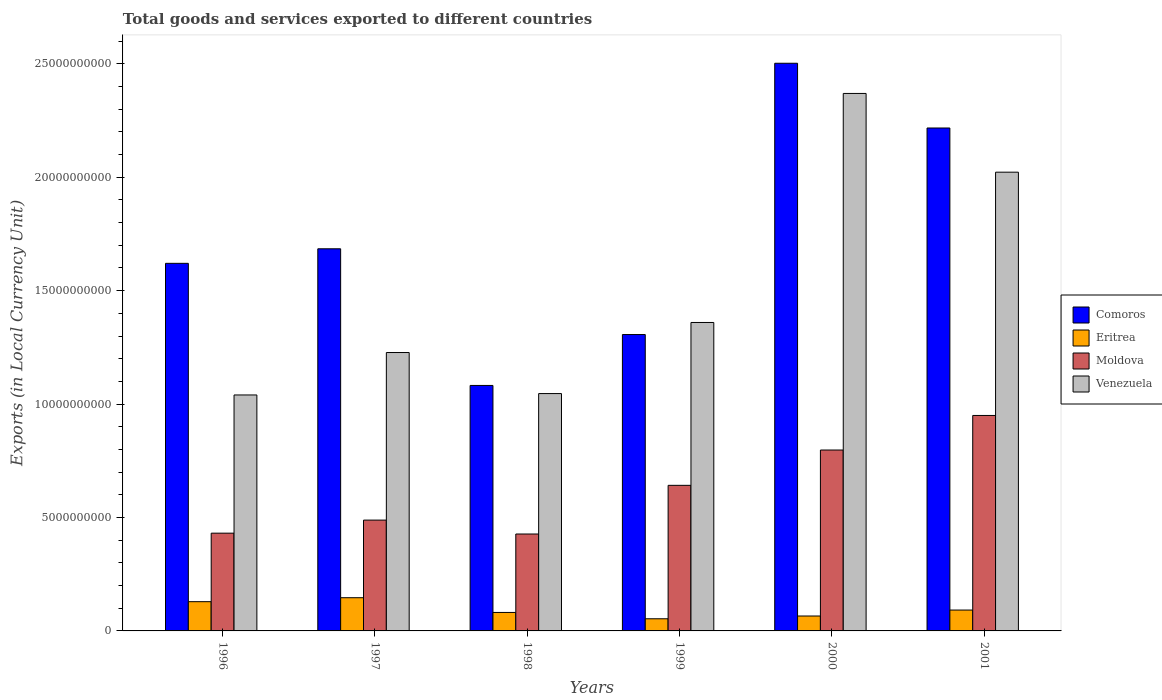How many groups of bars are there?
Provide a succinct answer. 6. Are the number of bars on each tick of the X-axis equal?
Offer a terse response. Yes. What is the Amount of goods and services exports in Venezuela in 2000?
Ensure brevity in your answer.  2.37e+1. Across all years, what is the maximum Amount of goods and services exports in Venezuela?
Make the answer very short. 2.37e+1. Across all years, what is the minimum Amount of goods and services exports in Eritrea?
Keep it short and to the point. 5.36e+08. In which year was the Amount of goods and services exports in Moldova maximum?
Give a very brief answer. 2001. What is the total Amount of goods and services exports in Venezuela in the graph?
Give a very brief answer. 9.06e+1. What is the difference between the Amount of goods and services exports in Moldova in 1998 and that in 1999?
Ensure brevity in your answer.  -2.15e+09. What is the difference between the Amount of goods and services exports in Venezuela in 1997 and the Amount of goods and services exports in Eritrea in 2001?
Your answer should be compact. 1.14e+1. What is the average Amount of goods and services exports in Venezuela per year?
Your answer should be compact. 1.51e+1. In the year 1998, what is the difference between the Amount of goods and services exports in Eritrea and Amount of goods and services exports in Comoros?
Offer a terse response. -1.00e+1. In how many years, is the Amount of goods and services exports in Comoros greater than 4000000000 LCU?
Provide a short and direct response. 6. What is the ratio of the Amount of goods and services exports in Venezuela in 1997 to that in 2000?
Your answer should be very brief. 0.52. Is the difference between the Amount of goods and services exports in Eritrea in 1999 and 2000 greater than the difference between the Amount of goods and services exports in Comoros in 1999 and 2000?
Your response must be concise. Yes. What is the difference between the highest and the second highest Amount of goods and services exports in Comoros?
Ensure brevity in your answer.  2.85e+09. What is the difference between the highest and the lowest Amount of goods and services exports in Venezuela?
Offer a terse response. 1.33e+1. In how many years, is the Amount of goods and services exports in Eritrea greater than the average Amount of goods and services exports in Eritrea taken over all years?
Your response must be concise. 2. Is it the case that in every year, the sum of the Amount of goods and services exports in Venezuela and Amount of goods and services exports in Comoros is greater than the sum of Amount of goods and services exports in Moldova and Amount of goods and services exports in Eritrea?
Keep it short and to the point. No. What does the 2nd bar from the left in 1997 represents?
Ensure brevity in your answer.  Eritrea. What does the 4th bar from the right in 2000 represents?
Your response must be concise. Comoros. Is it the case that in every year, the sum of the Amount of goods and services exports in Eritrea and Amount of goods and services exports in Comoros is greater than the Amount of goods and services exports in Venezuela?
Provide a succinct answer. Yes. How many years are there in the graph?
Offer a terse response. 6. What is the difference between two consecutive major ticks on the Y-axis?
Your answer should be compact. 5.00e+09. Are the values on the major ticks of Y-axis written in scientific E-notation?
Ensure brevity in your answer.  No. Where does the legend appear in the graph?
Your answer should be very brief. Center right. How many legend labels are there?
Your response must be concise. 4. How are the legend labels stacked?
Your answer should be compact. Vertical. What is the title of the graph?
Make the answer very short. Total goods and services exported to different countries. What is the label or title of the X-axis?
Keep it short and to the point. Years. What is the label or title of the Y-axis?
Provide a succinct answer. Exports (in Local Currency Unit). What is the Exports (in Local Currency Unit) of Comoros in 1996?
Your answer should be compact. 1.62e+1. What is the Exports (in Local Currency Unit) of Eritrea in 1996?
Give a very brief answer. 1.29e+09. What is the Exports (in Local Currency Unit) in Moldova in 1996?
Provide a short and direct response. 4.31e+09. What is the Exports (in Local Currency Unit) in Venezuela in 1996?
Offer a very short reply. 1.04e+1. What is the Exports (in Local Currency Unit) in Comoros in 1997?
Offer a very short reply. 1.68e+1. What is the Exports (in Local Currency Unit) of Eritrea in 1997?
Make the answer very short. 1.46e+09. What is the Exports (in Local Currency Unit) of Moldova in 1997?
Keep it short and to the point. 4.89e+09. What is the Exports (in Local Currency Unit) in Venezuela in 1997?
Provide a short and direct response. 1.23e+1. What is the Exports (in Local Currency Unit) in Comoros in 1998?
Keep it short and to the point. 1.08e+1. What is the Exports (in Local Currency Unit) in Eritrea in 1998?
Your answer should be compact. 8.14e+08. What is the Exports (in Local Currency Unit) in Moldova in 1998?
Ensure brevity in your answer.  4.27e+09. What is the Exports (in Local Currency Unit) in Venezuela in 1998?
Your answer should be very brief. 1.05e+1. What is the Exports (in Local Currency Unit) in Comoros in 1999?
Offer a terse response. 1.31e+1. What is the Exports (in Local Currency Unit) in Eritrea in 1999?
Your response must be concise. 5.36e+08. What is the Exports (in Local Currency Unit) of Moldova in 1999?
Give a very brief answer. 6.42e+09. What is the Exports (in Local Currency Unit) in Venezuela in 1999?
Ensure brevity in your answer.  1.36e+1. What is the Exports (in Local Currency Unit) in Comoros in 2000?
Provide a succinct answer. 2.50e+1. What is the Exports (in Local Currency Unit) of Eritrea in 2000?
Give a very brief answer. 6.57e+08. What is the Exports (in Local Currency Unit) of Moldova in 2000?
Offer a very short reply. 7.97e+09. What is the Exports (in Local Currency Unit) of Venezuela in 2000?
Give a very brief answer. 2.37e+1. What is the Exports (in Local Currency Unit) in Comoros in 2001?
Provide a short and direct response. 2.22e+1. What is the Exports (in Local Currency Unit) in Eritrea in 2001?
Ensure brevity in your answer.  9.20e+08. What is the Exports (in Local Currency Unit) in Moldova in 2001?
Your answer should be very brief. 9.50e+09. What is the Exports (in Local Currency Unit) in Venezuela in 2001?
Offer a terse response. 2.02e+1. Across all years, what is the maximum Exports (in Local Currency Unit) in Comoros?
Your answer should be very brief. 2.50e+1. Across all years, what is the maximum Exports (in Local Currency Unit) in Eritrea?
Offer a very short reply. 1.46e+09. Across all years, what is the maximum Exports (in Local Currency Unit) in Moldova?
Make the answer very short. 9.50e+09. Across all years, what is the maximum Exports (in Local Currency Unit) of Venezuela?
Provide a short and direct response. 2.37e+1. Across all years, what is the minimum Exports (in Local Currency Unit) of Comoros?
Your answer should be compact. 1.08e+1. Across all years, what is the minimum Exports (in Local Currency Unit) of Eritrea?
Provide a succinct answer. 5.36e+08. Across all years, what is the minimum Exports (in Local Currency Unit) in Moldova?
Provide a succinct answer. 4.27e+09. Across all years, what is the minimum Exports (in Local Currency Unit) in Venezuela?
Your answer should be compact. 1.04e+1. What is the total Exports (in Local Currency Unit) of Comoros in the graph?
Your answer should be compact. 1.04e+11. What is the total Exports (in Local Currency Unit) of Eritrea in the graph?
Provide a short and direct response. 5.68e+09. What is the total Exports (in Local Currency Unit) in Moldova in the graph?
Keep it short and to the point. 3.74e+1. What is the total Exports (in Local Currency Unit) of Venezuela in the graph?
Provide a short and direct response. 9.06e+1. What is the difference between the Exports (in Local Currency Unit) in Comoros in 1996 and that in 1997?
Give a very brief answer. -6.41e+08. What is the difference between the Exports (in Local Currency Unit) of Eritrea in 1996 and that in 1997?
Ensure brevity in your answer.  -1.75e+08. What is the difference between the Exports (in Local Currency Unit) of Moldova in 1996 and that in 1997?
Your response must be concise. -5.76e+08. What is the difference between the Exports (in Local Currency Unit) of Venezuela in 1996 and that in 1997?
Offer a terse response. -1.87e+09. What is the difference between the Exports (in Local Currency Unit) of Comoros in 1996 and that in 1998?
Offer a terse response. 5.38e+09. What is the difference between the Exports (in Local Currency Unit) in Eritrea in 1996 and that in 1998?
Offer a terse response. 4.75e+08. What is the difference between the Exports (in Local Currency Unit) of Moldova in 1996 and that in 1998?
Offer a terse response. 3.70e+07. What is the difference between the Exports (in Local Currency Unit) in Venezuela in 1996 and that in 1998?
Offer a very short reply. -6.14e+07. What is the difference between the Exports (in Local Currency Unit) of Comoros in 1996 and that in 1999?
Make the answer very short. 3.14e+09. What is the difference between the Exports (in Local Currency Unit) of Eritrea in 1996 and that in 1999?
Provide a short and direct response. 7.53e+08. What is the difference between the Exports (in Local Currency Unit) in Moldova in 1996 and that in 1999?
Ensure brevity in your answer.  -2.11e+09. What is the difference between the Exports (in Local Currency Unit) of Venezuela in 1996 and that in 1999?
Ensure brevity in your answer.  -3.20e+09. What is the difference between the Exports (in Local Currency Unit) in Comoros in 1996 and that in 2000?
Offer a very short reply. -8.82e+09. What is the difference between the Exports (in Local Currency Unit) of Eritrea in 1996 and that in 2000?
Make the answer very short. 6.31e+08. What is the difference between the Exports (in Local Currency Unit) of Moldova in 1996 and that in 2000?
Keep it short and to the point. -3.66e+09. What is the difference between the Exports (in Local Currency Unit) in Venezuela in 1996 and that in 2000?
Your answer should be very brief. -1.33e+1. What is the difference between the Exports (in Local Currency Unit) in Comoros in 1996 and that in 2001?
Offer a very short reply. -5.97e+09. What is the difference between the Exports (in Local Currency Unit) in Eritrea in 1996 and that in 2001?
Offer a very short reply. 3.69e+08. What is the difference between the Exports (in Local Currency Unit) in Moldova in 1996 and that in 2001?
Your answer should be very brief. -5.19e+09. What is the difference between the Exports (in Local Currency Unit) in Venezuela in 1996 and that in 2001?
Give a very brief answer. -9.82e+09. What is the difference between the Exports (in Local Currency Unit) in Comoros in 1997 and that in 1998?
Provide a short and direct response. 6.02e+09. What is the difference between the Exports (in Local Currency Unit) of Eritrea in 1997 and that in 1998?
Keep it short and to the point. 6.50e+08. What is the difference between the Exports (in Local Currency Unit) of Moldova in 1997 and that in 1998?
Offer a very short reply. 6.13e+08. What is the difference between the Exports (in Local Currency Unit) of Venezuela in 1997 and that in 1998?
Make the answer very short. 1.81e+09. What is the difference between the Exports (in Local Currency Unit) of Comoros in 1997 and that in 1999?
Keep it short and to the point. 3.78e+09. What is the difference between the Exports (in Local Currency Unit) of Eritrea in 1997 and that in 1999?
Offer a very short reply. 9.28e+08. What is the difference between the Exports (in Local Currency Unit) in Moldova in 1997 and that in 1999?
Make the answer very short. -1.53e+09. What is the difference between the Exports (in Local Currency Unit) of Venezuela in 1997 and that in 1999?
Keep it short and to the point. -1.32e+09. What is the difference between the Exports (in Local Currency Unit) in Comoros in 1997 and that in 2000?
Make the answer very short. -8.18e+09. What is the difference between the Exports (in Local Currency Unit) in Eritrea in 1997 and that in 2000?
Offer a very short reply. 8.06e+08. What is the difference between the Exports (in Local Currency Unit) of Moldova in 1997 and that in 2000?
Make the answer very short. -3.09e+09. What is the difference between the Exports (in Local Currency Unit) of Venezuela in 1997 and that in 2000?
Offer a very short reply. -1.14e+1. What is the difference between the Exports (in Local Currency Unit) in Comoros in 1997 and that in 2001?
Keep it short and to the point. -5.32e+09. What is the difference between the Exports (in Local Currency Unit) in Eritrea in 1997 and that in 2001?
Provide a short and direct response. 5.44e+08. What is the difference between the Exports (in Local Currency Unit) in Moldova in 1997 and that in 2001?
Ensure brevity in your answer.  -4.61e+09. What is the difference between the Exports (in Local Currency Unit) in Venezuela in 1997 and that in 2001?
Give a very brief answer. -7.95e+09. What is the difference between the Exports (in Local Currency Unit) in Comoros in 1998 and that in 1999?
Provide a short and direct response. -2.24e+09. What is the difference between the Exports (in Local Currency Unit) in Eritrea in 1998 and that in 1999?
Your answer should be very brief. 2.79e+08. What is the difference between the Exports (in Local Currency Unit) of Moldova in 1998 and that in 1999?
Ensure brevity in your answer.  -2.15e+09. What is the difference between the Exports (in Local Currency Unit) of Venezuela in 1998 and that in 1999?
Offer a terse response. -3.13e+09. What is the difference between the Exports (in Local Currency Unit) in Comoros in 1998 and that in 2000?
Make the answer very short. -1.42e+1. What is the difference between the Exports (in Local Currency Unit) in Eritrea in 1998 and that in 2000?
Your answer should be very brief. 1.57e+08. What is the difference between the Exports (in Local Currency Unit) in Moldova in 1998 and that in 2000?
Keep it short and to the point. -3.70e+09. What is the difference between the Exports (in Local Currency Unit) in Venezuela in 1998 and that in 2000?
Your answer should be very brief. -1.32e+1. What is the difference between the Exports (in Local Currency Unit) in Comoros in 1998 and that in 2001?
Provide a succinct answer. -1.13e+1. What is the difference between the Exports (in Local Currency Unit) of Eritrea in 1998 and that in 2001?
Provide a succinct answer. -1.05e+08. What is the difference between the Exports (in Local Currency Unit) in Moldova in 1998 and that in 2001?
Give a very brief answer. -5.23e+09. What is the difference between the Exports (in Local Currency Unit) of Venezuela in 1998 and that in 2001?
Your response must be concise. -9.76e+09. What is the difference between the Exports (in Local Currency Unit) in Comoros in 1999 and that in 2000?
Keep it short and to the point. -1.20e+1. What is the difference between the Exports (in Local Currency Unit) in Eritrea in 1999 and that in 2000?
Your answer should be very brief. -1.22e+08. What is the difference between the Exports (in Local Currency Unit) in Moldova in 1999 and that in 2000?
Offer a very short reply. -1.56e+09. What is the difference between the Exports (in Local Currency Unit) of Venezuela in 1999 and that in 2000?
Offer a very short reply. -1.01e+1. What is the difference between the Exports (in Local Currency Unit) of Comoros in 1999 and that in 2001?
Offer a terse response. -9.10e+09. What is the difference between the Exports (in Local Currency Unit) in Eritrea in 1999 and that in 2001?
Your answer should be compact. -3.84e+08. What is the difference between the Exports (in Local Currency Unit) of Moldova in 1999 and that in 2001?
Provide a short and direct response. -3.08e+09. What is the difference between the Exports (in Local Currency Unit) of Venezuela in 1999 and that in 2001?
Keep it short and to the point. -6.63e+09. What is the difference between the Exports (in Local Currency Unit) in Comoros in 2000 and that in 2001?
Ensure brevity in your answer.  2.85e+09. What is the difference between the Exports (in Local Currency Unit) in Eritrea in 2000 and that in 2001?
Offer a very short reply. -2.62e+08. What is the difference between the Exports (in Local Currency Unit) in Moldova in 2000 and that in 2001?
Make the answer very short. -1.52e+09. What is the difference between the Exports (in Local Currency Unit) in Venezuela in 2000 and that in 2001?
Provide a succinct answer. 3.47e+09. What is the difference between the Exports (in Local Currency Unit) of Comoros in 1996 and the Exports (in Local Currency Unit) of Eritrea in 1997?
Your response must be concise. 1.47e+1. What is the difference between the Exports (in Local Currency Unit) in Comoros in 1996 and the Exports (in Local Currency Unit) in Moldova in 1997?
Your answer should be very brief. 1.13e+1. What is the difference between the Exports (in Local Currency Unit) in Comoros in 1996 and the Exports (in Local Currency Unit) in Venezuela in 1997?
Ensure brevity in your answer.  3.93e+09. What is the difference between the Exports (in Local Currency Unit) of Eritrea in 1996 and the Exports (in Local Currency Unit) of Moldova in 1997?
Ensure brevity in your answer.  -3.60e+09. What is the difference between the Exports (in Local Currency Unit) of Eritrea in 1996 and the Exports (in Local Currency Unit) of Venezuela in 1997?
Offer a very short reply. -1.10e+1. What is the difference between the Exports (in Local Currency Unit) of Moldova in 1996 and the Exports (in Local Currency Unit) of Venezuela in 1997?
Your answer should be compact. -7.96e+09. What is the difference between the Exports (in Local Currency Unit) of Comoros in 1996 and the Exports (in Local Currency Unit) of Eritrea in 1998?
Your answer should be very brief. 1.54e+1. What is the difference between the Exports (in Local Currency Unit) of Comoros in 1996 and the Exports (in Local Currency Unit) of Moldova in 1998?
Your response must be concise. 1.19e+1. What is the difference between the Exports (in Local Currency Unit) of Comoros in 1996 and the Exports (in Local Currency Unit) of Venezuela in 1998?
Give a very brief answer. 5.74e+09. What is the difference between the Exports (in Local Currency Unit) of Eritrea in 1996 and the Exports (in Local Currency Unit) of Moldova in 1998?
Your response must be concise. -2.98e+09. What is the difference between the Exports (in Local Currency Unit) in Eritrea in 1996 and the Exports (in Local Currency Unit) in Venezuela in 1998?
Provide a succinct answer. -9.17e+09. What is the difference between the Exports (in Local Currency Unit) of Moldova in 1996 and the Exports (in Local Currency Unit) of Venezuela in 1998?
Offer a very short reply. -6.15e+09. What is the difference between the Exports (in Local Currency Unit) of Comoros in 1996 and the Exports (in Local Currency Unit) of Eritrea in 1999?
Provide a short and direct response. 1.57e+1. What is the difference between the Exports (in Local Currency Unit) of Comoros in 1996 and the Exports (in Local Currency Unit) of Moldova in 1999?
Make the answer very short. 9.79e+09. What is the difference between the Exports (in Local Currency Unit) of Comoros in 1996 and the Exports (in Local Currency Unit) of Venezuela in 1999?
Your response must be concise. 2.61e+09. What is the difference between the Exports (in Local Currency Unit) of Eritrea in 1996 and the Exports (in Local Currency Unit) of Moldova in 1999?
Your answer should be very brief. -5.13e+09. What is the difference between the Exports (in Local Currency Unit) in Eritrea in 1996 and the Exports (in Local Currency Unit) in Venezuela in 1999?
Offer a very short reply. -1.23e+1. What is the difference between the Exports (in Local Currency Unit) of Moldova in 1996 and the Exports (in Local Currency Unit) of Venezuela in 1999?
Provide a short and direct response. -9.29e+09. What is the difference between the Exports (in Local Currency Unit) of Comoros in 1996 and the Exports (in Local Currency Unit) of Eritrea in 2000?
Provide a short and direct response. 1.55e+1. What is the difference between the Exports (in Local Currency Unit) of Comoros in 1996 and the Exports (in Local Currency Unit) of Moldova in 2000?
Keep it short and to the point. 8.23e+09. What is the difference between the Exports (in Local Currency Unit) of Comoros in 1996 and the Exports (in Local Currency Unit) of Venezuela in 2000?
Your answer should be compact. -7.49e+09. What is the difference between the Exports (in Local Currency Unit) of Eritrea in 1996 and the Exports (in Local Currency Unit) of Moldova in 2000?
Your answer should be compact. -6.69e+09. What is the difference between the Exports (in Local Currency Unit) in Eritrea in 1996 and the Exports (in Local Currency Unit) in Venezuela in 2000?
Your answer should be very brief. -2.24e+1. What is the difference between the Exports (in Local Currency Unit) in Moldova in 1996 and the Exports (in Local Currency Unit) in Venezuela in 2000?
Give a very brief answer. -1.94e+1. What is the difference between the Exports (in Local Currency Unit) in Comoros in 1996 and the Exports (in Local Currency Unit) in Eritrea in 2001?
Your response must be concise. 1.53e+1. What is the difference between the Exports (in Local Currency Unit) in Comoros in 1996 and the Exports (in Local Currency Unit) in Moldova in 2001?
Give a very brief answer. 6.71e+09. What is the difference between the Exports (in Local Currency Unit) in Comoros in 1996 and the Exports (in Local Currency Unit) in Venezuela in 2001?
Provide a short and direct response. -4.02e+09. What is the difference between the Exports (in Local Currency Unit) in Eritrea in 1996 and the Exports (in Local Currency Unit) in Moldova in 2001?
Offer a very short reply. -8.21e+09. What is the difference between the Exports (in Local Currency Unit) of Eritrea in 1996 and the Exports (in Local Currency Unit) of Venezuela in 2001?
Your answer should be very brief. -1.89e+1. What is the difference between the Exports (in Local Currency Unit) in Moldova in 1996 and the Exports (in Local Currency Unit) in Venezuela in 2001?
Make the answer very short. -1.59e+1. What is the difference between the Exports (in Local Currency Unit) of Comoros in 1997 and the Exports (in Local Currency Unit) of Eritrea in 1998?
Your answer should be compact. 1.60e+1. What is the difference between the Exports (in Local Currency Unit) of Comoros in 1997 and the Exports (in Local Currency Unit) of Moldova in 1998?
Your response must be concise. 1.26e+1. What is the difference between the Exports (in Local Currency Unit) in Comoros in 1997 and the Exports (in Local Currency Unit) in Venezuela in 1998?
Offer a very short reply. 6.38e+09. What is the difference between the Exports (in Local Currency Unit) of Eritrea in 1997 and the Exports (in Local Currency Unit) of Moldova in 1998?
Your answer should be very brief. -2.81e+09. What is the difference between the Exports (in Local Currency Unit) in Eritrea in 1997 and the Exports (in Local Currency Unit) in Venezuela in 1998?
Give a very brief answer. -9.00e+09. What is the difference between the Exports (in Local Currency Unit) in Moldova in 1997 and the Exports (in Local Currency Unit) in Venezuela in 1998?
Your answer should be very brief. -5.58e+09. What is the difference between the Exports (in Local Currency Unit) in Comoros in 1997 and the Exports (in Local Currency Unit) in Eritrea in 1999?
Offer a very short reply. 1.63e+1. What is the difference between the Exports (in Local Currency Unit) in Comoros in 1997 and the Exports (in Local Currency Unit) in Moldova in 1999?
Your answer should be very brief. 1.04e+1. What is the difference between the Exports (in Local Currency Unit) of Comoros in 1997 and the Exports (in Local Currency Unit) of Venezuela in 1999?
Provide a short and direct response. 3.25e+09. What is the difference between the Exports (in Local Currency Unit) in Eritrea in 1997 and the Exports (in Local Currency Unit) in Moldova in 1999?
Your answer should be very brief. -4.95e+09. What is the difference between the Exports (in Local Currency Unit) of Eritrea in 1997 and the Exports (in Local Currency Unit) of Venezuela in 1999?
Your answer should be very brief. -1.21e+1. What is the difference between the Exports (in Local Currency Unit) in Moldova in 1997 and the Exports (in Local Currency Unit) in Venezuela in 1999?
Make the answer very short. -8.71e+09. What is the difference between the Exports (in Local Currency Unit) in Comoros in 1997 and the Exports (in Local Currency Unit) in Eritrea in 2000?
Provide a succinct answer. 1.62e+1. What is the difference between the Exports (in Local Currency Unit) in Comoros in 1997 and the Exports (in Local Currency Unit) in Moldova in 2000?
Offer a terse response. 8.87e+09. What is the difference between the Exports (in Local Currency Unit) of Comoros in 1997 and the Exports (in Local Currency Unit) of Venezuela in 2000?
Your answer should be compact. -6.85e+09. What is the difference between the Exports (in Local Currency Unit) in Eritrea in 1997 and the Exports (in Local Currency Unit) in Moldova in 2000?
Offer a very short reply. -6.51e+09. What is the difference between the Exports (in Local Currency Unit) of Eritrea in 1997 and the Exports (in Local Currency Unit) of Venezuela in 2000?
Provide a short and direct response. -2.22e+1. What is the difference between the Exports (in Local Currency Unit) of Moldova in 1997 and the Exports (in Local Currency Unit) of Venezuela in 2000?
Provide a succinct answer. -1.88e+1. What is the difference between the Exports (in Local Currency Unit) of Comoros in 1997 and the Exports (in Local Currency Unit) of Eritrea in 2001?
Provide a succinct answer. 1.59e+1. What is the difference between the Exports (in Local Currency Unit) of Comoros in 1997 and the Exports (in Local Currency Unit) of Moldova in 2001?
Offer a very short reply. 7.35e+09. What is the difference between the Exports (in Local Currency Unit) in Comoros in 1997 and the Exports (in Local Currency Unit) in Venezuela in 2001?
Ensure brevity in your answer.  -3.38e+09. What is the difference between the Exports (in Local Currency Unit) of Eritrea in 1997 and the Exports (in Local Currency Unit) of Moldova in 2001?
Your response must be concise. -8.03e+09. What is the difference between the Exports (in Local Currency Unit) of Eritrea in 1997 and the Exports (in Local Currency Unit) of Venezuela in 2001?
Provide a short and direct response. -1.88e+1. What is the difference between the Exports (in Local Currency Unit) of Moldova in 1997 and the Exports (in Local Currency Unit) of Venezuela in 2001?
Make the answer very short. -1.53e+1. What is the difference between the Exports (in Local Currency Unit) of Comoros in 1998 and the Exports (in Local Currency Unit) of Eritrea in 1999?
Keep it short and to the point. 1.03e+1. What is the difference between the Exports (in Local Currency Unit) of Comoros in 1998 and the Exports (in Local Currency Unit) of Moldova in 1999?
Make the answer very short. 4.40e+09. What is the difference between the Exports (in Local Currency Unit) of Comoros in 1998 and the Exports (in Local Currency Unit) of Venezuela in 1999?
Make the answer very short. -2.78e+09. What is the difference between the Exports (in Local Currency Unit) in Eritrea in 1998 and the Exports (in Local Currency Unit) in Moldova in 1999?
Keep it short and to the point. -5.60e+09. What is the difference between the Exports (in Local Currency Unit) of Eritrea in 1998 and the Exports (in Local Currency Unit) of Venezuela in 1999?
Offer a very short reply. -1.28e+1. What is the difference between the Exports (in Local Currency Unit) in Moldova in 1998 and the Exports (in Local Currency Unit) in Venezuela in 1999?
Make the answer very short. -9.32e+09. What is the difference between the Exports (in Local Currency Unit) in Comoros in 1998 and the Exports (in Local Currency Unit) in Eritrea in 2000?
Your response must be concise. 1.02e+1. What is the difference between the Exports (in Local Currency Unit) in Comoros in 1998 and the Exports (in Local Currency Unit) in Moldova in 2000?
Provide a succinct answer. 2.85e+09. What is the difference between the Exports (in Local Currency Unit) of Comoros in 1998 and the Exports (in Local Currency Unit) of Venezuela in 2000?
Offer a very short reply. -1.29e+1. What is the difference between the Exports (in Local Currency Unit) in Eritrea in 1998 and the Exports (in Local Currency Unit) in Moldova in 2000?
Your answer should be compact. -7.16e+09. What is the difference between the Exports (in Local Currency Unit) of Eritrea in 1998 and the Exports (in Local Currency Unit) of Venezuela in 2000?
Provide a succinct answer. -2.29e+1. What is the difference between the Exports (in Local Currency Unit) in Moldova in 1998 and the Exports (in Local Currency Unit) in Venezuela in 2000?
Your answer should be very brief. -1.94e+1. What is the difference between the Exports (in Local Currency Unit) of Comoros in 1998 and the Exports (in Local Currency Unit) of Eritrea in 2001?
Provide a short and direct response. 9.90e+09. What is the difference between the Exports (in Local Currency Unit) in Comoros in 1998 and the Exports (in Local Currency Unit) in Moldova in 2001?
Give a very brief answer. 1.32e+09. What is the difference between the Exports (in Local Currency Unit) in Comoros in 1998 and the Exports (in Local Currency Unit) in Venezuela in 2001?
Offer a very short reply. -9.40e+09. What is the difference between the Exports (in Local Currency Unit) in Eritrea in 1998 and the Exports (in Local Currency Unit) in Moldova in 2001?
Your answer should be very brief. -8.68e+09. What is the difference between the Exports (in Local Currency Unit) of Eritrea in 1998 and the Exports (in Local Currency Unit) of Venezuela in 2001?
Your answer should be compact. -1.94e+1. What is the difference between the Exports (in Local Currency Unit) of Moldova in 1998 and the Exports (in Local Currency Unit) of Venezuela in 2001?
Offer a very short reply. -1.59e+1. What is the difference between the Exports (in Local Currency Unit) of Comoros in 1999 and the Exports (in Local Currency Unit) of Eritrea in 2000?
Your response must be concise. 1.24e+1. What is the difference between the Exports (in Local Currency Unit) in Comoros in 1999 and the Exports (in Local Currency Unit) in Moldova in 2000?
Offer a terse response. 5.09e+09. What is the difference between the Exports (in Local Currency Unit) of Comoros in 1999 and the Exports (in Local Currency Unit) of Venezuela in 2000?
Offer a terse response. -1.06e+1. What is the difference between the Exports (in Local Currency Unit) in Eritrea in 1999 and the Exports (in Local Currency Unit) in Moldova in 2000?
Offer a very short reply. -7.44e+09. What is the difference between the Exports (in Local Currency Unit) in Eritrea in 1999 and the Exports (in Local Currency Unit) in Venezuela in 2000?
Ensure brevity in your answer.  -2.32e+1. What is the difference between the Exports (in Local Currency Unit) of Moldova in 1999 and the Exports (in Local Currency Unit) of Venezuela in 2000?
Keep it short and to the point. -1.73e+1. What is the difference between the Exports (in Local Currency Unit) in Comoros in 1999 and the Exports (in Local Currency Unit) in Eritrea in 2001?
Keep it short and to the point. 1.21e+1. What is the difference between the Exports (in Local Currency Unit) in Comoros in 1999 and the Exports (in Local Currency Unit) in Moldova in 2001?
Ensure brevity in your answer.  3.57e+09. What is the difference between the Exports (in Local Currency Unit) of Comoros in 1999 and the Exports (in Local Currency Unit) of Venezuela in 2001?
Your answer should be compact. -7.16e+09. What is the difference between the Exports (in Local Currency Unit) in Eritrea in 1999 and the Exports (in Local Currency Unit) in Moldova in 2001?
Give a very brief answer. -8.96e+09. What is the difference between the Exports (in Local Currency Unit) of Eritrea in 1999 and the Exports (in Local Currency Unit) of Venezuela in 2001?
Provide a succinct answer. -1.97e+1. What is the difference between the Exports (in Local Currency Unit) in Moldova in 1999 and the Exports (in Local Currency Unit) in Venezuela in 2001?
Give a very brief answer. -1.38e+1. What is the difference between the Exports (in Local Currency Unit) of Comoros in 2000 and the Exports (in Local Currency Unit) of Eritrea in 2001?
Offer a terse response. 2.41e+1. What is the difference between the Exports (in Local Currency Unit) in Comoros in 2000 and the Exports (in Local Currency Unit) in Moldova in 2001?
Give a very brief answer. 1.55e+1. What is the difference between the Exports (in Local Currency Unit) of Comoros in 2000 and the Exports (in Local Currency Unit) of Venezuela in 2001?
Give a very brief answer. 4.80e+09. What is the difference between the Exports (in Local Currency Unit) of Eritrea in 2000 and the Exports (in Local Currency Unit) of Moldova in 2001?
Your answer should be very brief. -8.84e+09. What is the difference between the Exports (in Local Currency Unit) in Eritrea in 2000 and the Exports (in Local Currency Unit) in Venezuela in 2001?
Offer a terse response. -1.96e+1. What is the difference between the Exports (in Local Currency Unit) of Moldova in 2000 and the Exports (in Local Currency Unit) of Venezuela in 2001?
Provide a short and direct response. -1.22e+1. What is the average Exports (in Local Currency Unit) of Comoros per year?
Offer a very short reply. 1.74e+1. What is the average Exports (in Local Currency Unit) of Eritrea per year?
Your answer should be very brief. 9.47e+08. What is the average Exports (in Local Currency Unit) in Moldova per year?
Make the answer very short. 6.23e+09. What is the average Exports (in Local Currency Unit) in Venezuela per year?
Offer a terse response. 1.51e+1. In the year 1996, what is the difference between the Exports (in Local Currency Unit) in Comoros and Exports (in Local Currency Unit) in Eritrea?
Provide a succinct answer. 1.49e+1. In the year 1996, what is the difference between the Exports (in Local Currency Unit) of Comoros and Exports (in Local Currency Unit) of Moldova?
Provide a short and direct response. 1.19e+1. In the year 1996, what is the difference between the Exports (in Local Currency Unit) of Comoros and Exports (in Local Currency Unit) of Venezuela?
Give a very brief answer. 5.80e+09. In the year 1996, what is the difference between the Exports (in Local Currency Unit) in Eritrea and Exports (in Local Currency Unit) in Moldova?
Offer a terse response. -3.02e+09. In the year 1996, what is the difference between the Exports (in Local Currency Unit) of Eritrea and Exports (in Local Currency Unit) of Venezuela?
Offer a very short reply. -9.11e+09. In the year 1996, what is the difference between the Exports (in Local Currency Unit) of Moldova and Exports (in Local Currency Unit) of Venezuela?
Offer a terse response. -6.09e+09. In the year 1997, what is the difference between the Exports (in Local Currency Unit) in Comoros and Exports (in Local Currency Unit) in Eritrea?
Offer a very short reply. 1.54e+1. In the year 1997, what is the difference between the Exports (in Local Currency Unit) of Comoros and Exports (in Local Currency Unit) of Moldova?
Offer a terse response. 1.20e+1. In the year 1997, what is the difference between the Exports (in Local Currency Unit) of Comoros and Exports (in Local Currency Unit) of Venezuela?
Provide a short and direct response. 4.57e+09. In the year 1997, what is the difference between the Exports (in Local Currency Unit) in Eritrea and Exports (in Local Currency Unit) in Moldova?
Keep it short and to the point. -3.42e+09. In the year 1997, what is the difference between the Exports (in Local Currency Unit) of Eritrea and Exports (in Local Currency Unit) of Venezuela?
Offer a terse response. -1.08e+1. In the year 1997, what is the difference between the Exports (in Local Currency Unit) in Moldova and Exports (in Local Currency Unit) in Venezuela?
Provide a succinct answer. -7.39e+09. In the year 1998, what is the difference between the Exports (in Local Currency Unit) in Comoros and Exports (in Local Currency Unit) in Eritrea?
Your response must be concise. 1.00e+1. In the year 1998, what is the difference between the Exports (in Local Currency Unit) of Comoros and Exports (in Local Currency Unit) of Moldova?
Provide a succinct answer. 6.55e+09. In the year 1998, what is the difference between the Exports (in Local Currency Unit) of Comoros and Exports (in Local Currency Unit) of Venezuela?
Make the answer very short. 3.58e+08. In the year 1998, what is the difference between the Exports (in Local Currency Unit) in Eritrea and Exports (in Local Currency Unit) in Moldova?
Make the answer very short. -3.46e+09. In the year 1998, what is the difference between the Exports (in Local Currency Unit) of Eritrea and Exports (in Local Currency Unit) of Venezuela?
Your response must be concise. -9.65e+09. In the year 1998, what is the difference between the Exports (in Local Currency Unit) in Moldova and Exports (in Local Currency Unit) in Venezuela?
Your answer should be compact. -6.19e+09. In the year 1999, what is the difference between the Exports (in Local Currency Unit) of Comoros and Exports (in Local Currency Unit) of Eritrea?
Keep it short and to the point. 1.25e+1. In the year 1999, what is the difference between the Exports (in Local Currency Unit) in Comoros and Exports (in Local Currency Unit) in Moldova?
Give a very brief answer. 6.65e+09. In the year 1999, what is the difference between the Exports (in Local Currency Unit) of Comoros and Exports (in Local Currency Unit) of Venezuela?
Ensure brevity in your answer.  -5.32e+08. In the year 1999, what is the difference between the Exports (in Local Currency Unit) in Eritrea and Exports (in Local Currency Unit) in Moldova?
Offer a terse response. -5.88e+09. In the year 1999, what is the difference between the Exports (in Local Currency Unit) of Eritrea and Exports (in Local Currency Unit) of Venezuela?
Give a very brief answer. -1.31e+1. In the year 1999, what is the difference between the Exports (in Local Currency Unit) of Moldova and Exports (in Local Currency Unit) of Venezuela?
Ensure brevity in your answer.  -7.18e+09. In the year 2000, what is the difference between the Exports (in Local Currency Unit) in Comoros and Exports (in Local Currency Unit) in Eritrea?
Give a very brief answer. 2.44e+1. In the year 2000, what is the difference between the Exports (in Local Currency Unit) in Comoros and Exports (in Local Currency Unit) in Moldova?
Your answer should be very brief. 1.70e+1. In the year 2000, what is the difference between the Exports (in Local Currency Unit) in Comoros and Exports (in Local Currency Unit) in Venezuela?
Your response must be concise. 1.33e+09. In the year 2000, what is the difference between the Exports (in Local Currency Unit) in Eritrea and Exports (in Local Currency Unit) in Moldova?
Offer a very short reply. -7.32e+09. In the year 2000, what is the difference between the Exports (in Local Currency Unit) in Eritrea and Exports (in Local Currency Unit) in Venezuela?
Keep it short and to the point. -2.30e+1. In the year 2000, what is the difference between the Exports (in Local Currency Unit) in Moldova and Exports (in Local Currency Unit) in Venezuela?
Ensure brevity in your answer.  -1.57e+1. In the year 2001, what is the difference between the Exports (in Local Currency Unit) in Comoros and Exports (in Local Currency Unit) in Eritrea?
Ensure brevity in your answer.  2.13e+1. In the year 2001, what is the difference between the Exports (in Local Currency Unit) in Comoros and Exports (in Local Currency Unit) in Moldova?
Keep it short and to the point. 1.27e+1. In the year 2001, what is the difference between the Exports (in Local Currency Unit) of Comoros and Exports (in Local Currency Unit) of Venezuela?
Provide a succinct answer. 1.95e+09. In the year 2001, what is the difference between the Exports (in Local Currency Unit) in Eritrea and Exports (in Local Currency Unit) in Moldova?
Give a very brief answer. -8.58e+09. In the year 2001, what is the difference between the Exports (in Local Currency Unit) of Eritrea and Exports (in Local Currency Unit) of Venezuela?
Offer a very short reply. -1.93e+1. In the year 2001, what is the difference between the Exports (in Local Currency Unit) of Moldova and Exports (in Local Currency Unit) of Venezuela?
Your response must be concise. -1.07e+1. What is the ratio of the Exports (in Local Currency Unit) in Comoros in 1996 to that in 1997?
Offer a terse response. 0.96. What is the ratio of the Exports (in Local Currency Unit) of Eritrea in 1996 to that in 1997?
Keep it short and to the point. 0.88. What is the ratio of the Exports (in Local Currency Unit) of Moldova in 1996 to that in 1997?
Keep it short and to the point. 0.88. What is the ratio of the Exports (in Local Currency Unit) in Venezuela in 1996 to that in 1997?
Keep it short and to the point. 0.85. What is the ratio of the Exports (in Local Currency Unit) in Comoros in 1996 to that in 1998?
Your answer should be compact. 1.5. What is the ratio of the Exports (in Local Currency Unit) of Eritrea in 1996 to that in 1998?
Ensure brevity in your answer.  1.58. What is the ratio of the Exports (in Local Currency Unit) of Moldova in 1996 to that in 1998?
Offer a very short reply. 1.01. What is the ratio of the Exports (in Local Currency Unit) of Comoros in 1996 to that in 1999?
Offer a very short reply. 1.24. What is the ratio of the Exports (in Local Currency Unit) of Eritrea in 1996 to that in 1999?
Provide a short and direct response. 2.41. What is the ratio of the Exports (in Local Currency Unit) in Moldova in 1996 to that in 1999?
Give a very brief answer. 0.67. What is the ratio of the Exports (in Local Currency Unit) in Venezuela in 1996 to that in 1999?
Your answer should be compact. 0.77. What is the ratio of the Exports (in Local Currency Unit) of Comoros in 1996 to that in 2000?
Your response must be concise. 0.65. What is the ratio of the Exports (in Local Currency Unit) in Eritrea in 1996 to that in 2000?
Your answer should be very brief. 1.96. What is the ratio of the Exports (in Local Currency Unit) in Moldova in 1996 to that in 2000?
Your answer should be compact. 0.54. What is the ratio of the Exports (in Local Currency Unit) of Venezuela in 1996 to that in 2000?
Your answer should be very brief. 0.44. What is the ratio of the Exports (in Local Currency Unit) of Comoros in 1996 to that in 2001?
Give a very brief answer. 0.73. What is the ratio of the Exports (in Local Currency Unit) of Eritrea in 1996 to that in 2001?
Provide a short and direct response. 1.4. What is the ratio of the Exports (in Local Currency Unit) in Moldova in 1996 to that in 2001?
Offer a very short reply. 0.45. What is the ratio of the Exports (in Local Currency Unit) in Venezuela in 1996 to that in 2001?
Provide a succinct answer. 0.51. What is the ratio of the Exports (in Local Currency Unit) of Comoros in 1997 to that in 1998?
Offer a very short reply. 1.56. What is the ratio of the Exports (in Local Currency Unit) of Eritrea in 1997 to that in 1998?
Your answer should be compact. 1.8. What is the ratio of the Exports (in Local Currency Unit) in Moldova in 1997 to that in 1998?
Make the answer very short. 1.14. What is the ratio of the Exports (in Local Currency Unit) of Venezuela in 1997 to that in 1998?
Give a very brief answer. 1.17. What is the ratio of the Exports (in Local Currency Unit) of Comoros in 1997 to that in 1999?
Your answer should be very brief. 1.29. What is the ratio of the Exports (in Local Currency Unit) in Eritrea in 1997 to that in 1999?
Offer a terse response. 2.73. What is the ratio of the Exports (in Local Currency Unit) of Moldova in 1997 to that in 1999?
Keep it short and to the point. 0.76. What is the ratio of the Exports (in Local Currency Unit) in Venezuela in 1997 to that in 1999?
Your answer should be compact. 0.9. What is the ratio of the Exports (in Local Currency Unit) of Comoros in 1997 to that in 2000?
Provide a short and direct response. 0.67. What is the ratio of the Exports (in Local Currency Unit) of Eritrea in 1997 to that in 2000?
Give a very brief answer. 2.23. What is the ratio of the Exports (in Local Currency Unit) of Moldova in 1997 to that in 2000?
Your response must be concise. 0.61. What is the ratio of the Exports (in Local Currency Unit) of Venezuela in 1997 to that in 2000?
Ensure brevity in your answer.  0.52. What is the ratio of the Exports (in Local Currency Unit) of Comoros in 1997 to that in 2001?
Offer a very short reply. 0.76. What is the ratio of the Exports (in Local Currency Unit) in Eritrea in 1997 to that in 2001?
Your answer should be very brief. 1.59. What is the ratio of the Exports (in Local Currency Unit) of Moldova in 1997 to that in 2001?
Offer a terse response. 0.51. What is the ratio of the Exports (in Local Currency Unit) in Venezuela in 1997 to that in 2001?
Your answer should be very brief. 0.61. What is the ratio of the Exports (in Local Currency Unit) of Comoros in 1998 to that in 1999?
Your response must be concise. 0.83. What is the ratio of the Exports (in Local Currency Unit) of Eritrea in 1998 to that in 1999?
Ensure brevity in your answer.  1.52. What is the ratio of the Exports (in Local Currency Unit) of Moldova in 1998 to that in 1999?
Ensure brevity in your answer.  0.67. What is the ratio of the Exports (in Local Currency Unit) of Venezuela in 1998 to that in 1999?
Make the answer very short. 0.77. What is the ratio of the Exports (in Local Currency Unit) of Comoros in 1998 to that in 2000?
Your answer should be compact. 0.43. What is the ratio of the Exports (in Local Currency Unit) in Eritrea in 1998 to that in 2000?
Provide a short and direct response. 1.24. What is the ratio of the Exports (in Local Currency Unit) of Moldova in 1998 to that in 2000?
Make the answer very short. 0.54. What is the ratio of the Exports (in Local Currency Unit) in Venezuela in 1998 to that in 2000?
Provide a succinct answer. 0.44. What is the ratio of the Exports (in Local Currency Unit) in Comoros in 1998 to that in 2001?
Offer a very short reply. 0.49. What is the ratio of the Exports (in Local Currency Unit) in Eritrea in 1998 to that in 2001?
Offer a terse response. 0.89. What is the ratio of the Exports (in Local Currency Unit) of Moldova in 1998 to that in 2001?
Provide a succinct answer. 0.45. What is the ratio of the Exports (in Local Currency Unit) of Venezuela in 1998 to that in 2001?
Provide a succinct answer. 0.52. What is the ratio of the Exports (in Local Currency Unit) of Comoros in 1999 to that in 2000?
Your answer should be compact. 0.52. What is the ratio of the Exports (in Local Currency Unit) in Eritrea in 1999 to that in 2000?
Provide a short and direct response. 0.81. What is the ratio of the Exports (in Local Currency Unit) in Moldova in 1999 to that in 2000?
Your response must be concise. 0.8. What is the ratio of the Exports (in Local Currency Unit) of Venezuela in 1999 to that in 2000?
Keep it short and to the point. 0.57. What is the ratio of the Exports (in Local Currency Unit) of Comoros in 1999 to that in 2001?
Keep it short and to the point. 0.59. What is the ratio of the Exports (in Local Currency Unit) in Eritrea in 1999 to that in 2001?
Keep it short and to the point. 0.58. What is the ratio of the Exports (in Local Currency Unit) of Moldova in 1999 to that in 2001?
Offer a terse response. 0.68. What is the ratio of the Exports (in Local Currency Unit) in Venezuela in 1999 to that in 2001?
Your response must be concise. 0.67. What is the ratio of the Exports (in Local Currency Unit) of Comoros in 2000 to that in 2001?
Give a very brief answer. 1.13. What is the ratio of the Exports (in Local Currency Unit) of Eritrea in 2000 to that in 2001?
Give a very brief answer. 0.71. What is the ratio of the Exports (in Local Currency Unit) of Moldova in 2000 to that in 2001?
Provide a short and direct response. 0.84. What is the ratio of the Exports (in Local Currency Unit) in Venezuela in 2000 to that in 2001?
Ensure brevity in your answer.  1.17. What is the difference between the highest and the second highest Exports (in Local Currency Unit) of Comoros?
Give a very brief answer. 2.85e+09. What is the difference between the highest and the second highest Exports (in Local Currency Unit) of Eritrea?
Keep it short and to the point. 1.75e+08. What is the difference between the highest and the second highest Exports (in Local Currency Unit) of Moldova?
Offer a terse response. 1.52e+09. What is the difference between the highest and the second highest Exports (in Local Currency Unit) in Venezuela?
Ensure brevity in your answer.  3.47e+09. What is the difference between the highest and the lowest Exports (in Local Currency Unit) in Comoros?
Offer a very short reply. 1.42e+1. What is the difference between the highest and the lowest Exports (in Local Currency Unit) of Eritrea?
Your answer should be very brief. 9.28e+08. What is the difference between the highest and the lowest Exports (in Local Currency Unit) in Moldova?
Keep it short and to the point. 5.23e+09. What is the difference between the highest and the lowest Exports (in Local Currency Unit) of Venezuela?
Provide a succinct answer. 1.33e+1. 